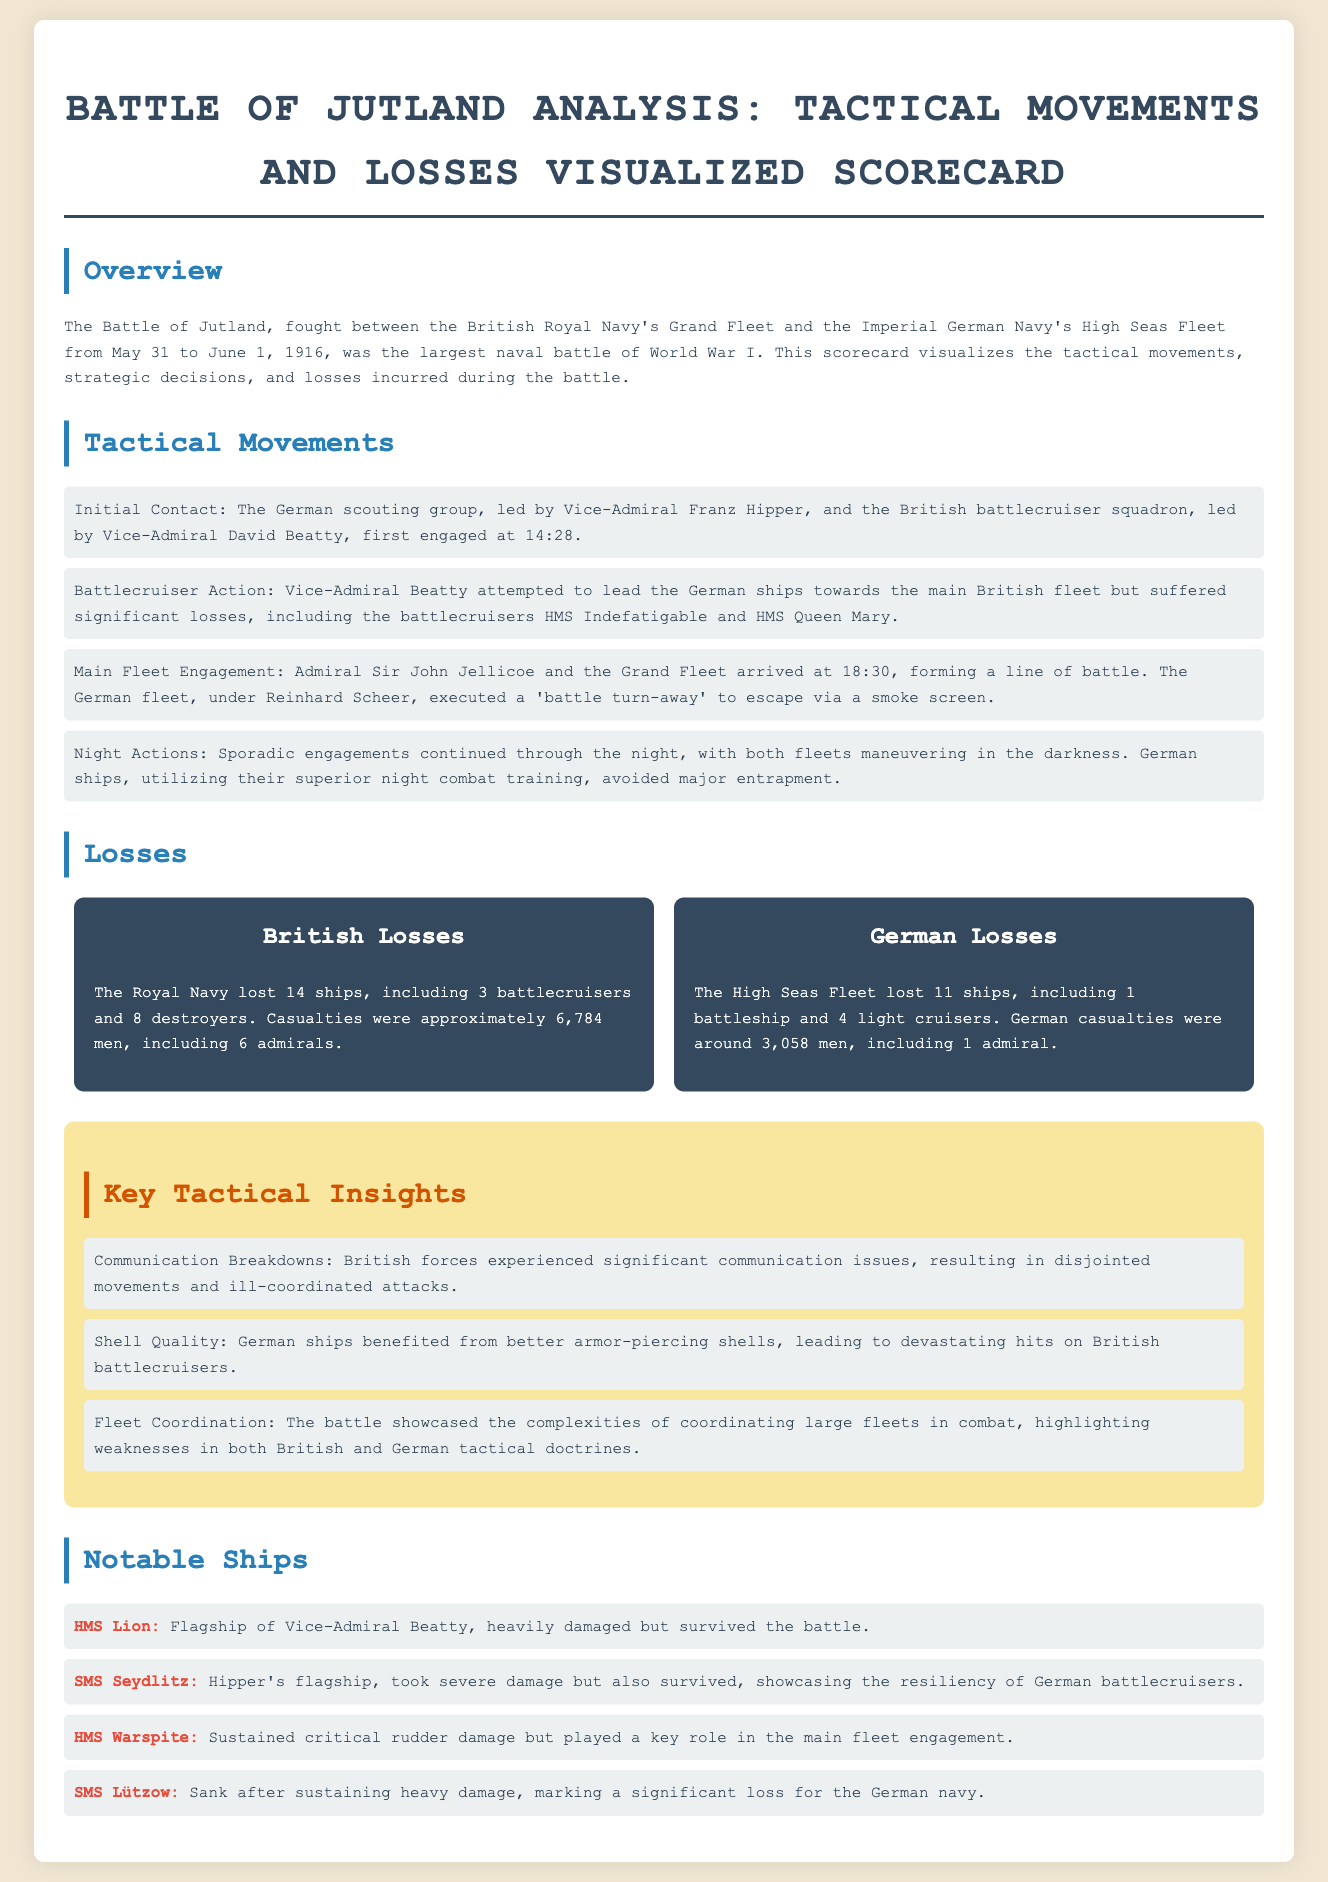What was the date range of the Battle of Jutland? The document states that the battle took place from May 31 to June 1, 1916.
Answer: May 31 to June 1, 1916 How many British ships were lost during the battle? The document specifies that the Royal Navy lost 14 ships during the conflict.
Answer: 14 ships What was the name of the flagship of Vice-Admiral Beatty? The document identifies HMS Lion as Beatty's flagship in the overview of notable ships.
Answer: HMS Lion Which German ship sank after sustaining heavy damage? According to the document, SMS Lützow sank after taking heavy damage during the battle.
Answer: SMS Lützow What was a significant communication issue faced by British forces? The scorecard mentions that British forces experienced significant communication breakdowns.
Answer: Communication breakdowns Which fleet executed a 'battle turn-away'? The document states that the German fleet, under Reinhard Scheer, executed a 'battle turn-away'.
Answer: German fleet How many casualties did the British royal navy incur? The losses section details that British casualties were approximately 6,784 men.
Answer: 6,784 men What type of shells did German ships benefit from? The tactical insights section notes that German ships had better armor-piercing shells.
Answer: Armor-piercing shells 